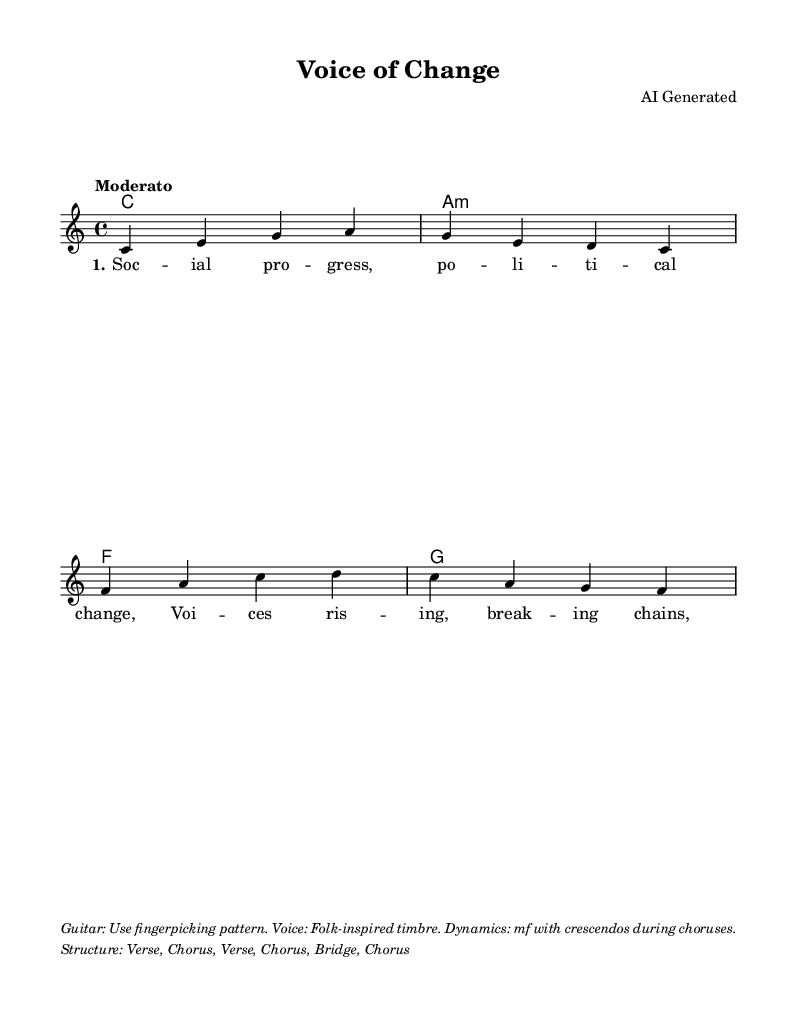What is the key signature of this music? The key signature is C major, which has no sharps or flats indicated. The musical notes start at C and fit within the scale of C major.
Answer: C major What is the time signature of this music? The time signature is 4/4, shown at the beginning of the score, indicating four beats per measure with a quarter note receiving one beat.
Answer: 4/4 What is the tempo marking for this music? The tempo marking is "Moderato," which suggests a moderate pace, typically ranging from 96 to 108 beats per minute.
Answer: Moderato How many measures are in the melody? By counting the bars in the melody section, we observe that there are a total of 8 measures, as each measure is separated by a vertical line.
Answer: 8 measures What is the structure of the song as indicated in the markup? The structure of the song includes a sequence of Verse, Chorus, Verse, Chorus, Bridge, and finally a Chorus, illustrating the form of the piece.
Answer: Verse, Chorus, Verse, Chorus, Bridge, Chorus What dynamic marking is suggested for the voice? The dynamic marking suggested is "mf," which stands for mezzo-forte, indicating a moderately loud sound, along with crescendos during choruses.
Answer: mf What type of guitar technique is recommended for this piece? The sheet music suggests using a fingerpicking pattern for the guitar, which is a specific playing technique commonly used in folk music.
Answer: Fingerpicking 